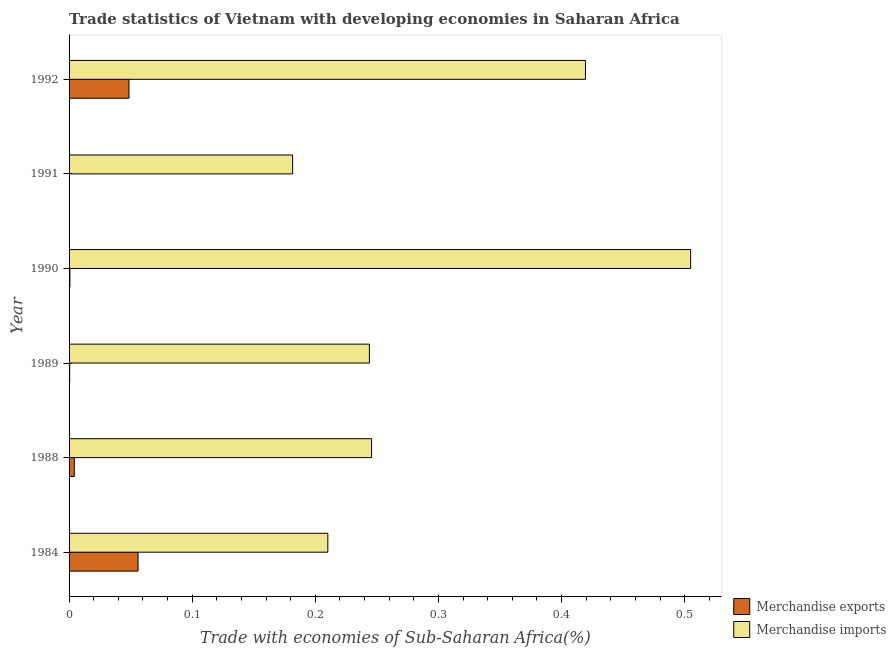How many groups of bars are there?
Offer a very short reply. 6. Are the number of bars per tick equal to the number of legend labels?
Offer a very short reply. Yes. How many bars are there on the 2nd tick from the top?
Ensure brevity in your answer.  2. What is the label of the 3rd group of bars from the top?
Ensure brevity in your answer.  1990. What is the merchandise imports in 1992?
Offer a very short reply. 0.42. Across all years, what is the maximum merchandise exports?
Give a very brief answer. 0.06. Across all years, what is the minimum merchandise exports?
Offer a very short reply. 0. In which year was the merchandise imports maximum?
Give a very brief answer. 1990. What is the total merchandise exports in the graph?
Your response must be concise. 0.11. What is the difference between the merchandise imports in 1990 and that in 1992?
Keep it short and to the point. 0.09. What is the difference between the merchandise exports in 1990 and the merchandise imports in 1992?
Offer a terse response. -0.42. What is the average merchandise exports per year?
Ensure brevity in your answer.  0.02. In the year 1991, what is the difference between the merchandise imports and merchandise exports?
Keep it short and to the point. 0.18. What is the ratio of the merchandise imports in 1990 to that in 1992?
Offer a very short reply. 1.2. Is the merchandise exports in 1991 less than that in 1992?
Offer a terse response. Yes. What is the difference between the highest and the second highest merchandise imports?
Offer a very short reply. 0.09. What is the difference between the highest and the lowest merchandise imports?
Provide a short and direct response. 0.32. In how many years, is the merchandise exports greater than the average merchandise exports taken over all years?
Your answer should be very brief. 2. What does the 1st bar from the top in 1988 represents?
Give a very brief answer. Merchandise imports. How many bars are there?
Your response must be concise. 12. Are all the bars in the graph horizontal?
Your answer should be compact. Yes. How many years are there in the graph?
Ensure brevity in your answer.  6. What is the difference between two consecutive major ticks on the X-axis?
Ensure brevity in your answer.  0.1. Are the values on the major ticks of X-axis written in scientific E-notation?
Provide a short and direct response. No. Does the graph contain grids?
Offer a very short reply. No. How are the legend labels stacked?
Your answer should be compact. Vertical. What is the title of the graph?
Your answer should be compact. Trade statistics of Vietnam with developing economies in Saharan Africa. Does "Long-term debt" appear as one of the legend labels in the graph?
Offer a very short reply. No. What is the label or title of the X-axis?
Offer a terse response. Trade with economies of Sub-Saharan Africa(%). What is the label or title of the Y-axis?
Provide a succinct answer. Year. What is the Trade with economies of Sub-Saharan Africa(%) of Merchandise exports in 1984?
Provide a succinct answer. 0.06. What is the Trade with economies of Sub-Saharan Africa(%) in Merchandise imports in 1984?
Provide a short and direct response. 0.21. What is the Trade with economies of Sub-Saharan Africa(%) of Merchandise exports in 1988?
Provide a short and direct response. 0. What is the Trade with economies of Sub-Saharan Africa(%) of Merchandise imports in 1988?
Ensure brevity in your answer.  0.25. What is the Trade with economies of Sub-Saharan Africa(%) of Merchandise exports in 1989?
Your response must be concise. 0. What is the Trade with economies of Sub-Saharan Africa(%) in Merchandise imports in 1989?
Your response must be concise. 0.24. What is the Trade with economies of Sub-Saharan Africa(%) in Merchandise exports in 1990?
Ensure brevity in your answer.  0. What is the Trade with economies of Sub-Saharan Africa(%) of Merchandise imports in 1990?
Your response must be concise. 0.5. What is the Trade with economies of Sub-Saharan Africa(%) of Merchandise exports in 1991?
Offer a terse response. 0. What is the Trade with economies of Sub-Saharan Africa(%) in Merchandise imports in 1991?
Provide a short and direct response. 0.18. What is the Trade with economies of Sub-Saharan Africa(%) of Merchandise exports in 1992?
Your response must be concise. 0.05. What is the Trade with economies of Sub-Saharan Africa(%) of Merchandise imports in 1992?
Your response must be concise. 0.42. Across all years, what is the maximum Trade with economies of Sub-Saharan Africa(%) of Merchandise exports?
Make the answer very short. 0.06. Across all years, what is the maximum Trade with economies of Sub-Saharan Africa(%) in Merchandise imports?
Provide a short and direct response. 0.5. Across all years, what is the minimum Trade with economies of Sub-Saharan Africa(%) in Merchandise exports?
Offer a terse response. 0. Across all years, what is the minimum Trade with economies of Sub-Saharan Africa(%) of Merchandise imports?
Give a very brief answer. 0.18. What is the total Trade with economies of Sub-Saharan Africa(%) in Merchandise exports in the graph?
Your answer should be compact. 0.11. What is the total Trade with economies of Sub-Saharan Africa(%) in Merchandise imports in the graph?
Provide a succinct answer. 1.81. What is the difference between the Trade with economies of Sub-Saharan Africa(%) of Merchandise exports in 1984 and that in 1988?
Provide a short and direct response. 0.05. What is the difference between the Trade with economies of Sub-Saharan Africa(%) in Merchandise imports in 1984 and that in 1988?
Make the answer very short. -0.04. What is the difference between the Trade with economies of Sub-Saharan Africa(%) in Merchandise exports in 1984 and that in 1989?
Offer a very short reply. 0.06. What is the difference between the Trade with economies of Sub-Saharan Africa(%) in Merchandise imports in 1984 and that in 1989?
Give a very brief answer. -0.03. What is the difference between the Trade with economies of Sub-Saharan Africa(%) of Merchandise exports in 1984 and that in 1990?
Your response must be concise. 0.06. What is the difference between the Trade with economies of Sub-Saharan Africa(%) of Merchandise imports in 1984 and that in 1990?
Offer a very short reply. -0.29. What is the difference between the Trade with economies of Sub-Saharan Africa(%) in Merchandise exports in 1984 and that in 1991?
Give a very brief answer. 0.06. What is the difference between the Trade with economies of Sub-Saharan Africa(%) in Merchandise imports in 1984 and that in 1991?
Your answer should be compact. 0.03. What is the difference between the Trade with economies of Sub-Saharan Africa(%) in Merchandise exports in 1984 and that in 1992?
Your response must be concise. 0.01. What is the difference between the Trade with economies of Sub-Saharan Africa(%) in Merchandise imports in 1984 and that in 1992?
Keep it short and to the point. -0.21. What is the difference between the Trade with economies of Sub-Saharan Africa(%) in Merchandise exports in 1988 and that in 1989?
Your response must be concise. 0. What is the difference between the Trade with economies of Sub-Saharan Africa(%) in Merchandise imports in 1988 and that in 1989?
Keep it short and to the point. 0. What is the difference between the Trade with economies of Sub-Saharan Africa(%) of Merchandise exports in 1988 and that in 1990?
Keep it short and to the point. 0. What is the difference between the Trade with economies of Sub-Saharan Africa(%) in Merchandise imports in 1988 and that in 1990?
Offer a terse response. -0.26. What is the difference between the Trade with economies of Sub-Saharan Africa(%) in Merchandise exports in 1988 and that in 1991?
Your answer should be compact. 0. What is the difference between the Trade with economies of Sub-Saharan Africa(%) in Merchandise imports in 1988 and that in 1991?
Offer a terse response. 0.06. What is the difference between the Trade with economies of Sub-Saharan Africa(%) of Merchandise exports in 1988 and that in 1992?
Your answer should be compact. -0.04. What is the difference between the Trade with economies of Sub-Saharan Africa(%) of Merchandise imports in 1988 and that in 1992?
Give a very brief answer. -0.17. What is the difference between the Trade with economies of Sub-Saharan Africa(%) of Merchandise exports in 1989 and that in 1990?
Your answer should be very brief. -0. What is the difference between the Trade with economies of Sub-Saharan Africa(%) of Merchandise imports in 1989 and that in 1990?
Provide a succinct answer. -0.26. What is the difference between the Trade with economies of Sub-Saharan Africa(%) in Merchandise exports in 1989 and that in 1991?
Offer a very short reply. 0. What is the difference between the Trade with economies of Sub-Saharan Africa(%) in Merchandise imports in 1989 and that in 1991?
Offer a very short reply. 0.06. What is the difference between the Trade with economies of Sub-Saharan Africa(%) in Merchandise exports in 1989 and that in 1992?
Provide a succinct answer. -0.05. What is the difference between the Trade with economies of Sub-Saharan Africa(%) in Merchandise imports in 1989 and that in 1992?
Your answer should be very brief. -0.18. What is the difference between the Trade with economies of Sub-Saharan Africa(%) of Merchandise imports in 1990 and that in 1991?
Offer a terse response. 0.32. What is the difference between the Trade with economies of Sub-Saharan Africa(%) in Merchandise exports in 1990 and that in 1992?
Ensure brevity in your answer.  -0.05. What is the difference between the Trade with economies of Sub-Saharan Africa(%) of Merchandise imports in 1990 and that in 1992?
Your response must be concise. 0.09. What is the difference between the Trade with economies of Sub-Saharan Africa(%) in Merchandise exports in 1991 and that in 1992?
Your answer should be very brief. -0.05. What is the difference between the Trade with economies of Sub-Saharan Africa(%) of Merchandise imports in 1991 and that in 1992?
Provide a succinct answer. -0.24. What is the difference between the Trade with economies of Sub-Saharan Africa(%) in Merchandise exports in 1984 and the Trade with economies of Sub-Saharan Africa(%) in Merchandise imports in 1988?
Keep it short and to the point. -0.19. What is the difference between the Trade with economies of Sub-Saharan Africa(%) in Merchandise exports in 1984 and the Trade with economies of Sub-Saharan Africa(%) in Merchandise imports in 1989?
Offer a very short reply. -0.19. What is the difference between the Trade with economies of Sub-Saharan Africa(%) in Merchandise exports in 1984 and the Trade with economies of Sub-Saharan Africa(%) in Merchandise imports in 1990?
Ensure brevity in your answer.  -0.45. What is the difference between the Trade with economies of Sub-Saharan Africa(%) in Merchandise exports in 1984 and the Trade with economies of Sub-Saharan Africa(%) in Merchandise imports in 1991?
Your answer should be compact. -0.13. What is the difference between the Trade with economies of Sub-Saharan Africa(%) of Merchandise exports in 1984 and the Trade with economies of Sub-Saharan Africa(%) of Merchandise imports in 1992?
Your answer should be compact. -0.36. What is the difference between the Trade with economies of Sub-Saharan Africa(%) of Merchandise exports in 1988 and the Trade with economies of Sub-Saharan Africa(%) of Merchandise imports in 1989?
Offer a terse response. -0.24. What is the difference between the Trade with economies of Sub-Saharan Africa(%) of Merchandise exports in 1988 and the Trade with economies of Sub-Saharan Africa(%) of Merchandise imports in 1990?
Offer a terse response. -0.5. What is the difference between the Trade with economies of Sub-Saharan Africa(%) in Merchandise exports in 1988 and the Trade with economies of Sub-Saharan Africa(%) in Merchandise imports in 1991?
Offer a terse response. -0.18. What is the difference between the Trade with economies of Sub-Saharan Africa(%) in Merchandise exports in 1988 and the Trade with economies of Sub-Saharan Africa(%) in Merchandise imports in 1992?
Your answer should be very brief. -0.42. What is the difference between the Trade with economies of Sub-Saharan Africa(%) in Merchandise exports in 1989 and the Trade with economies of Sub-Saharan Africa(%) in Merchandise imports in 1990?
Provide a short and direct response. -0.5. What is the difference between the Trade with economies of Sub-Saharan Africa(%) of Merchandise exports in 1989 and the Trade with economies of Sub-Saharan Africa(%) of Merchandise imports in 1991?
Provide a succinct answer. -0.18. What is the difference between the Trade with economies of Sub-Saharan Africa(%) of Merchandise exports in 1989 and the Trade with economies of Sub-Saharan Africa(%) of Merchandise imports in 1992?
Provide a short and direct response. -0.42. What is the difference between the Trade with economies of Sub-Saharan Africa(%) in Merchandise exports in 1990 and the Trade with economies of Sub-Saharan Africa(%) in Merchandise imports in 1991?
Offer a terse response. -0.18. What is the difference between the Trade with economies of Sub-Saharan Africa(%) of Merchandise exports in 1990 and the Trade with economies of Sub-Saharan Africa(%) of Merchandise imports in 1992?
Provide a short and direct response. -0.42. What is the difference between the Trade with economies of Sub-Saharan Africa(%) of Merchandise exports in 1991 and the Trade with economies of Sub-Saharan Africa(%) of Merchandise imports in 1992?
Give a very brief answer. -0.42. What is the average Trade with economies of Sub-Saharan Africa(%) of Merchandise exports per year?
Your response must be concise. 0.02. What is the average Trade with economies of Sub-Saharan Africa(%) of Merchandise imports per year?
Make the answer very short. 0.3. In the year 1984, what is the difference between the Trade with economies of Sub-Saharan Africa(%) in Merchandise exports and Trade with economies of Sub-Saharan Africa(%) in Merchandise imports?
Your answer should be very brief. -0.15. In the year 1988, what is the difference between the Trade with economies of Sub-Saharan Africa(%) in Merchandise exports and Trade with economies of Sub-Saharan Africa(%) in Merchandise imports?
Provide a succinct answer. -0.24. In the year 1989, what is the difference between the Trade with economies of Sub-Saharan Africa(%) in Merchandise exports and Trade with economies of Sub-Saharan Africa(%) in Merchandise imports?
Offer a very short reply. -0.24. In the year 1990, what is the difference between the Trade with economies of Sub-Saharan Africa(%) of Merchandise exports and Trade with economies of Sub-Saharan Africa(%) of Merchandise imports?
Offer a terse response. -0.5. In the year 1991, what is the difference between the Trade with economies of Sub-Saharan Africa(%) of Merchandise exports and Trade with economies of Sub-Saharan Africa(%) of Merchandise imports?
Provide a short and direct response. -0.18. In the year 1992, what is the difference between the Trade with economies of Sub-Saharan Africa(%) in Merchandise exports and Trade with economies of Sub-Saharan Africa(%) in Merchandise imports?
Your answer should be very brief. -0.37. What is the ratio of the Trade with economies of Sub-Saharan Africa(%) in Merchandise exports in 1984 to that in 1988?
Your response must be concise. 13.22. What is the ratio of the Trade with economies of Sub-Saharan Africa(%) of Merchandise imports in 1984 to that in 1988?
Offer a very short reply. 0.86. What is the ratio of the Trade with economies of Sub-Saharan Africa(%) of Merchandise exports in 1984 to that in 1989?
Offer a very short reply. 115.43. What is the ratio of the Trade with economies of Sub-Saharan Africa(%) in Merchandise imports in 1984 to that in 1989?
Give a very brief answer. 0.86. What is the ratio of the Trade with economies of Sub-Saharan Africa(%) of Merchandise exports in 1984 to that in 1990?
Give a very brief answer. 83.2. What is the ratio of the Trade with economies of Sub-Saharan Africa(%) in Merchandise imports in 1984 to that in 1990?
Ensure brevity in your answer.  0.42. What is the ratio of the Trade with economies of Sub-Saharan Africa(%) in Merchandise exports in 1984 to that in 1991?
Provide a succinct answer. 204.39. What is the ratio of the Trade with economies of Sub-Saharan Africa(%) in Merchandise imports in 1984 to that in 1991?
Your answer should be compact. 1.16. What is the ratio of the Trade with economies of Sub-Saharan Africa(%) in Merchandise exports in 1984 to that in 1992?
Give a very brief answer. 1.15. What is the ratio of the Trade with economies of Sub-Saharan Africa(%) of Merchandise imports in 1984 to that in 1992?
Your response must be concise. 0.5. What is the ratio of the Trade with economies of Sub-Saharan Africa(%) of Merchandise exports in 1988 to that in 1989?
Offer a terse response. 8.73. What is the ratio of the Trade with economies of Sub-Saharan Africa(%) in Merchandise imports in 1988 to that in 1989?
Your response must be concise. 1.01. What is the ratio of the Trade with economies of Sub-Saharan Africa(%) in Merchandise exports in 1988 to that in 1990?
Offer a terse response. 6.29. What is the ratio of the Trade with economies of Sub-Saharan Africa(%) in Merchandise imports in 1988 to that in 1990?
Your answer should be very brief. 0.49. What is the ratio of the Trade with economies of Sub-Saharan Africa(%) of Merchandise exports in 1988 to that in 1991?
Provide a succinct answer. 15.46. What is the ratio of the Trade with economies of Sub-Saharan Africa(%) of Merchandise imports in 1988 to that in 1991?
Offer a terse response. 1.35. What is the ratio of the Trade with economies of Sub-Saharan Africa(%) in Merchandise exports in 1988 to that in 1992?
Provide a short and direct response. 0.09. What is the ratio of the Trade with economies of Sub-Saharan Africa(%) in Merchandise imports in 1988 to that in 1992?
Offer a terse response. 0.59. What is the ratio of the Trade with economies of Sub-Saharan Africa(%) in Merchandise exports in 1989 to that in 1990?
Offer a very short reply. 0.72. What is the ratio of the Trade with economies of Sub-Saharan Africa(%) in Merchandise imports in 1989 to that in 1990?
Give a very brief answer. 0.48. What is the ratio of the Trade with economies of Sub-Saharan Africa(%) of Merchandise exports in 1989 to that in 1991?
Provide a short and direct response. 1.77. What is the ratio of the Trade with economies of Sub-Saharan Africa(%) in Merchandise imports in 1989 to that in 1991?
Offer a terse response. 1.34. What is the ratio of the Trade with economies of Sub-Saharan Africa(%) in Merchandise imports in 1989 to that in 1992?
Give a very brief answer. 0.58. What is the ratio of the Trade with economies of Sub-Saharan Africa(%) in Merchandise exports in 1990 to that in 1991?
Your answer should be very brief. 2.46. What is the ratio of the Trade with economies of Sub-Saharan Africa(%) in Merchandise imports in 1990 to that in 1991?
Provide a succinct answer. 2.78. What is the ratio of the Trade with economies of Sub-Saharan Africa(%) in Merchandise exports in 1990 to that in 1992?
Make the answer very short. 0.01. What is the ratio of the Trade with economies of Sub-Saharan Africa(%) of Merchandise imports in 1990 to that in 1992?
Your answer should be compact. 1.2. What is the ratio of the Trade with economies of Sub-Saharan Africa(%) of Merchandise exports in 1991 to that in 1992?
Provide a short and direct response. 0.01. What is the ratio of the Trade with economies of Sub-Saharan Africa(%) in Merchandise imports in 1991 to that in 1992?
Offer a terse response. 0.43. What is the difference between the highest and the second highest Trade with economies of Sub-Saharan Africa(%) of Merchandise exports?
Offer a terse response. 0.01. What is the difference between the highest and the second highest Trade with economies of Sub-Saharan Africa(%) in Merchandise imports?
Keep it short and to the point. 0.09. What is the difference between the highest and the lowest Trade with economies of Sub-Saharan Africa(%) of Merchandise exports?
Give a very brief answer. 0.06. What is the difference between the highest and the lowest Trade with economies of Sub-Saharan Africa(%) in Merchandise imports?
Provide a short and direct response. 0.32. 